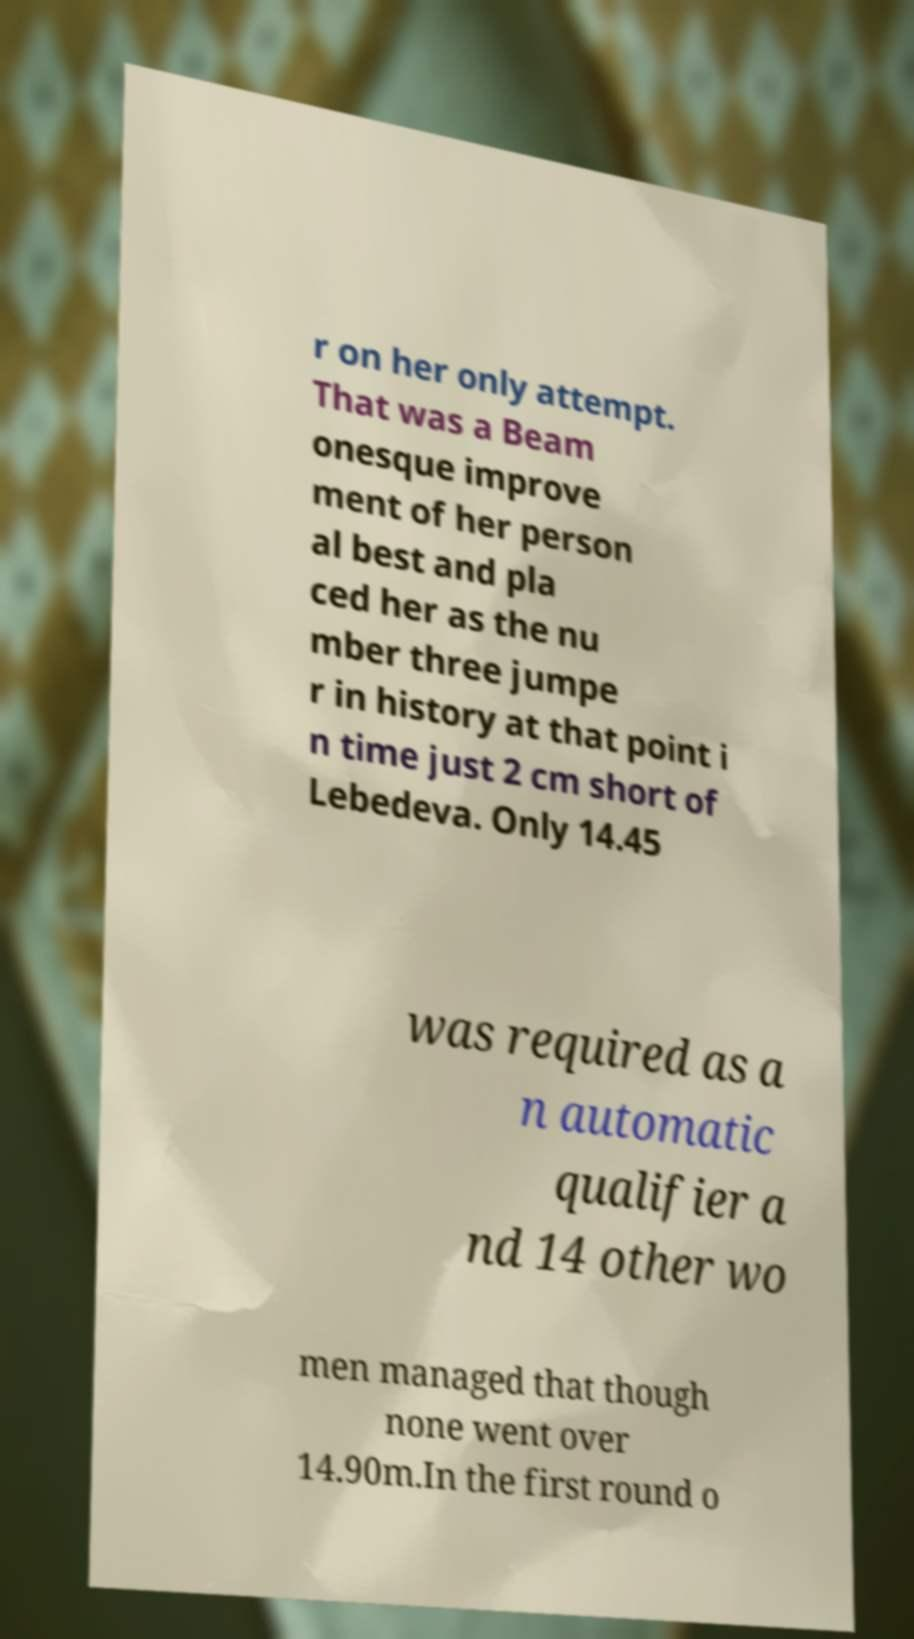There's text embedded in this image that I need extracted. Can you transcribe it verbatim? r on her only attempt. That was a Beam onesque improve ment of her person al best and pla ced her as the nu mber three jumpe r in history at that point i n time just 2 cm short of Lebedeva. Only 14.45 was required as a n automatic qualifier a nd 14 other wo men managed that though none went over 14.90m.In the first round o 